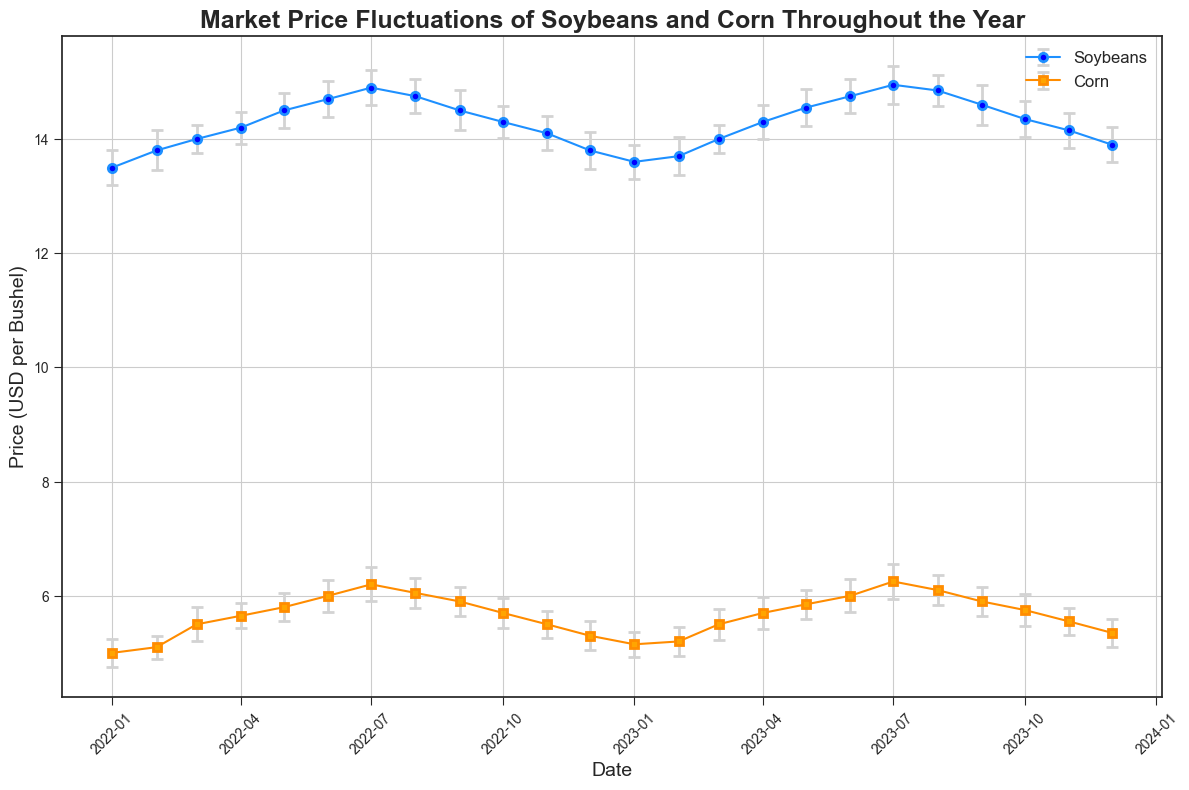Which crop shows higher average price volatility throughout the year? To determine price volatility, compare the standard deviation of prices over the year for both crops. Soybeans' standard deviation ranges mostly around 0.3 and varies up to 0.35, while corn's standard deviation ranges between 0.2 and 0.3. Soybeans have a slightly larger average standard deviation.
Answer: Soybeans During which month do soybeans and corn prices reach their highest levels? Look at the plot and identify the highest points for both soybeans and corn. Soybeans peak in July 2023 and corn peaks in July 2023 as well.
Answer: July 2023 How does the price of corn in August 2023 compare to its price in July 2023? Observe the corn prices for July 2023 and August 2023. The price in July 2023 is about 6.25, while in August 2023 it is around 6.10, showing a decrease.
Answer: Decreased Is there a month where the error bars for both soybeans and corn prices are relatively small? Examine the length of the error bars throughout the year. Both soybeans and corn have relatively small error bars in April 2022, indicating less price variability.
Answer: April 2022 What is the trend of soybean prices from January 2022 to December 2022? Follow the soybean price line from January 2022 to December 2022. The prices trend upwards, peaking around July, and then trend downwards.
Answer: Increasing then decreasing How do the October 2023 soybean and corn prices compare? Check the prices in October 2023 for both crops. Soybeans are around 14.35, while corn is around 5.75, indicating higher soybean prices.
Answer: Soybeans are higher Are soybean prices in December 2023 higher, lower, or about the same as in January 2022? Compare the soybean prices in December 2023 and January 2022. In January 2022, the price is about 13.50 while in December 2023 it is about 13.90, showing an increase.
Answer: Higher What month has the smallest standard deviation in corn prices, indicating less price fluctuation? Identify the month with the smallest error bar length for corn. July 2022 has one of the smallest standard deviations at 0.2.
Answer: July 2022 What are the price changes and trends for soybeans and corn from June 2023 to July 2023? Examine the price change for both crops from June 2023 to July 2023. Soybeans increase slightly from 14.75 to 14.95, and corn increases from 6.00 to 6.25. Both show an upward trend.
Answer: Both increased 